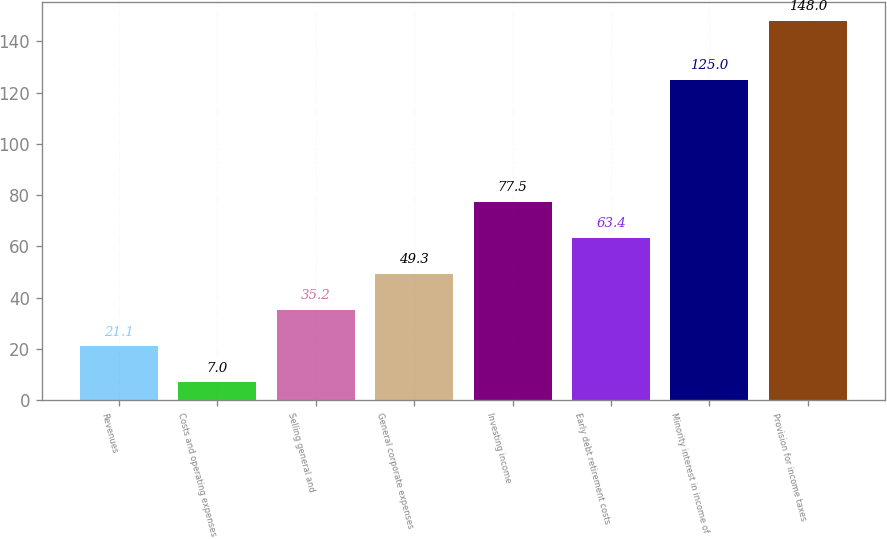<chart> <loc_0><loc_0><loc_500><loc_500><bar_chart><fcel>Revenues<fcel>Costs and operating expenses<fcel>Selling general and<fcel>General corporate expenses<fcel>Investing income<fcel>Early debt retirement costs<fcel>Minority interest in income of<fcel>Provision for income taxes<nl><fcel>21.1<fcel>7<fcel>35.2<fcel>49.3<fcel>77.5<fcel>63.4<fcel>125<fcel>148<nl></chart> 